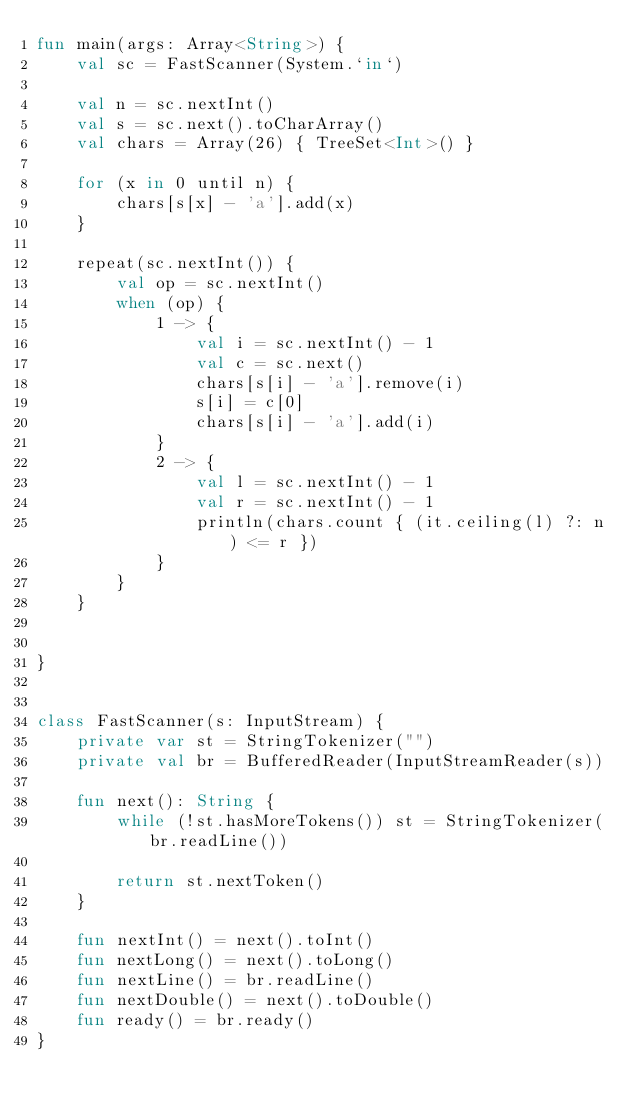<code> <loc_0><loc_0><loc_500><loc_500><_Kotlin_>fun main(args: Array<String>) {
    val sc = FastScanner(System.`in`)

    val n = sc.nextInt()
    val s = sc.next().toCharArray()
    val chars = Array(26) { TreeSet<Int>() }

    for (x in 0 until n) {
        chars[s[x] - 'a'].add(x)
    }

    repeat(sc.nextInt()) {
        val op = sc.nextInt()
        when (op) {
            1 -> {
                val i = sc.nextInt() - 1
                val c = sc.next()
                chars[s[i] - 'a'].remove(i)
                s[i] = c[0]
                chars[s[i] - 'a'].add(i)
            }
            2 -> {
                val l = sc.nextInt() - 1
                val r = sc.nextInt() - 1
                println(chars.count { (it.ceiling(l) ?: n) <= r })
            }
        }
    }


}


class FastScanner(s: InputStream) {
    private var st = StringTokenizer("")
    private val br = BufferedReader(InputStreamReader(s))

    fun next(): String {
        while (!st.hasMoreTokens()) st = StringTokenizer(br.readLine())

        return st.nextToken()
    }

    fun nextInt() = next().toInt()
    fun nextLong() = next().toLong()
    fun nextLine() = br.readLine()
    fun nextDouble() = next().toDouble()
    fun ready() = br.ready()
}
</code> 